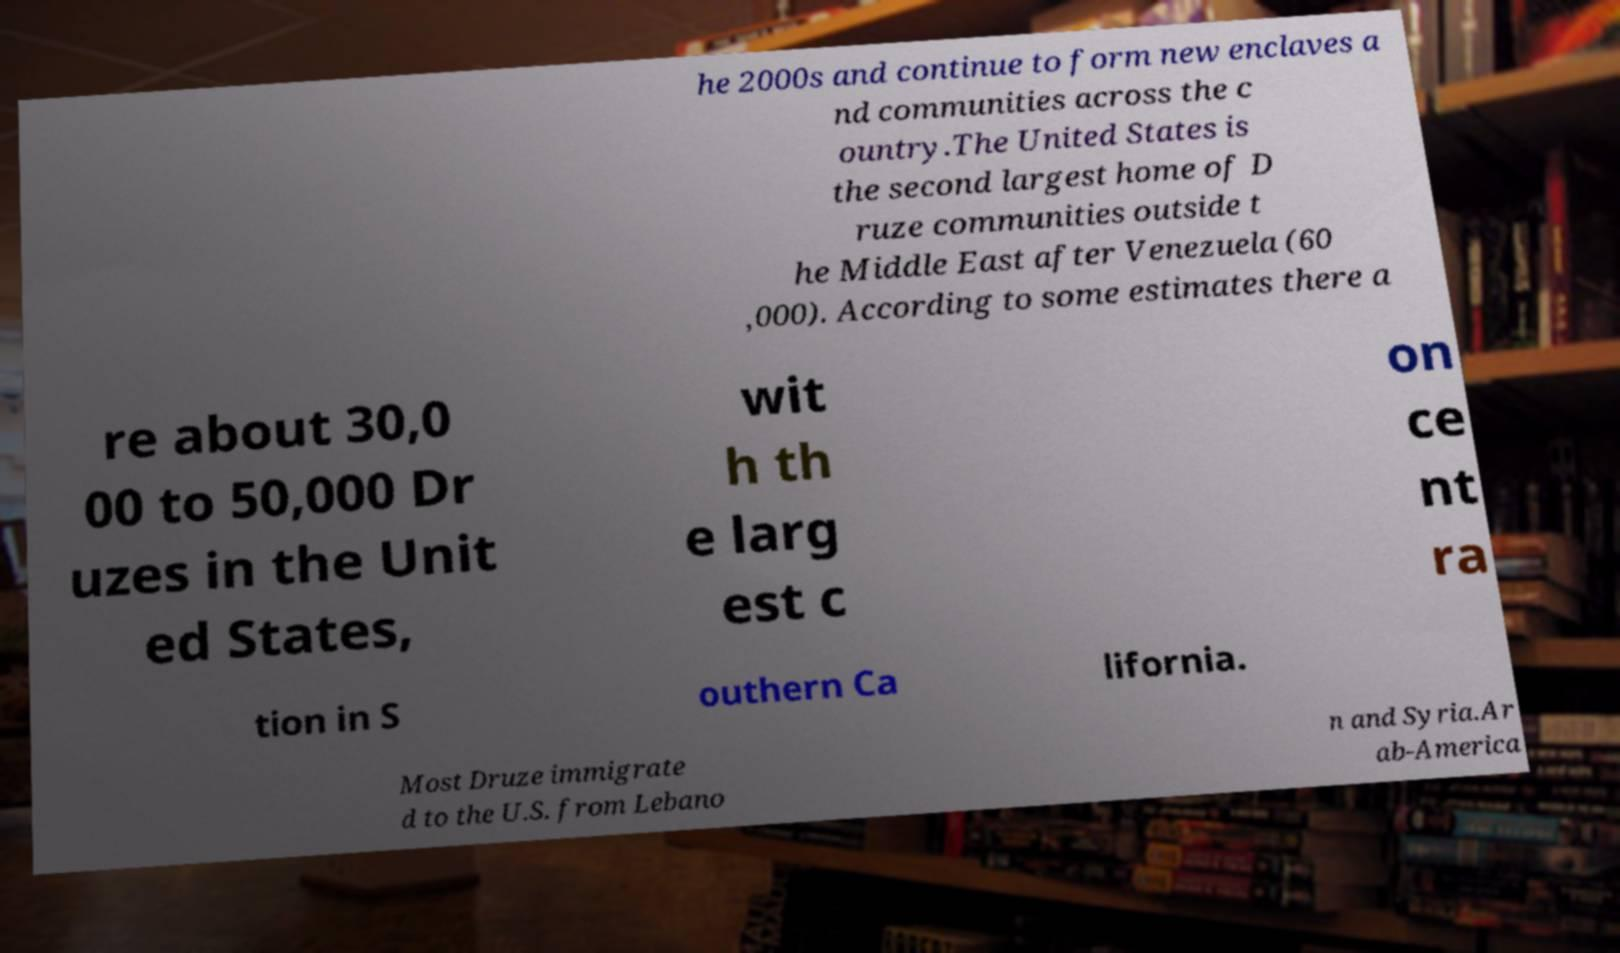Could you assist in decoding the text presented in this image and type it out clearly? he 2000s and continue to form new enclaves a nd communities across the c ountry.The United States is the second largest home of D ruze communities outside t he Middle East after Venezuela (60 ,000). According to some estimates there a re about 30,0 00 to 50,000 Dr uzes in the Unit ed States, wit h th e larg est c on ce nt ra tion in S outhern Ca lifornia. Most Druze immigrate d to the U.S. from Lebano n and Syria.Ar ab-America 